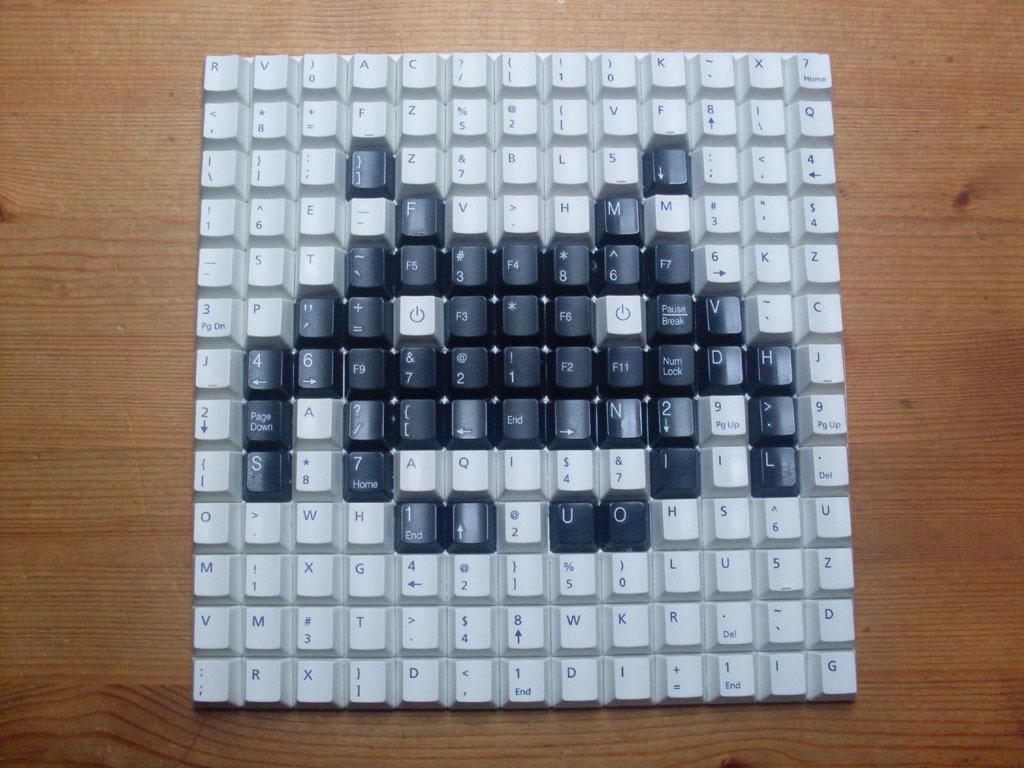What is the last key in the bottom right?
Provide a succinct answer. G. What letter is on the black key on the very bottom right of the keyboard?
Provide a short and direct response. O. 